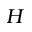Convert formula to latex. <formula><loc_0><loc_0><loc_500><loc_500>H</formula> 